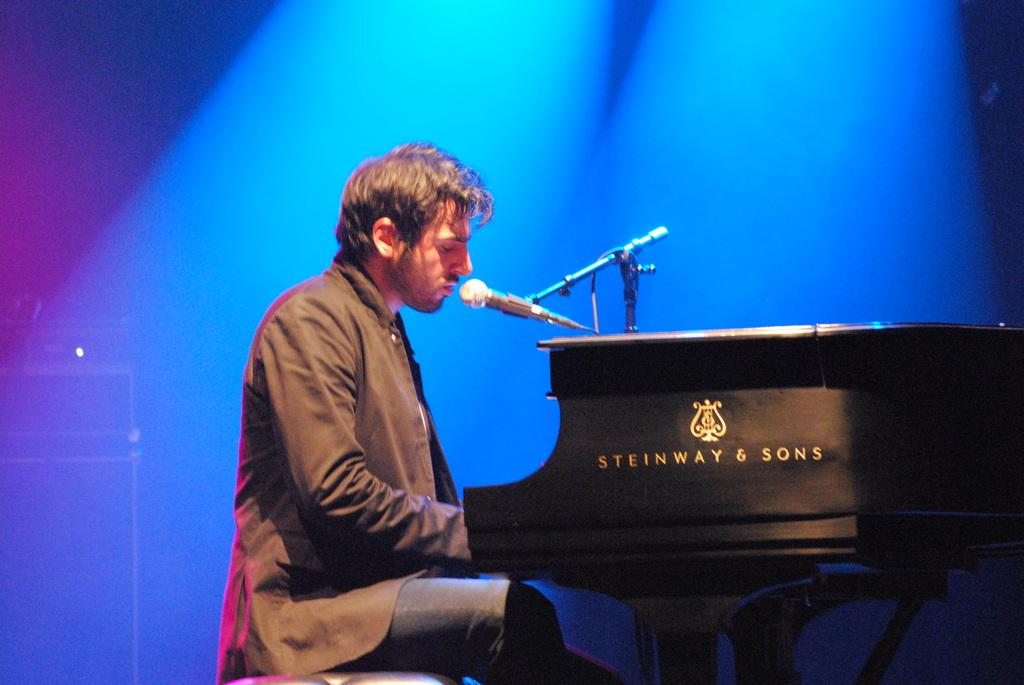Who is present in the image? There is a man in the image. What is the man doing in the image? The man is sitting on a stool in the image. What objects are related to music in the image? There is a piano, a microphone, and a stand in the image. What other object can be seen in the image? There is a wire in the image. What is located on the left side of the image? There are boxes on the left side of the image. What grade does the man receive for his performance in the library? There is no indication of a performance or a library in the image, and therefore no grade can be assigned. 